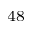<formula> <loc_0><loc_0><loc_500><loc_500>^ { 4 8 }</formula> 